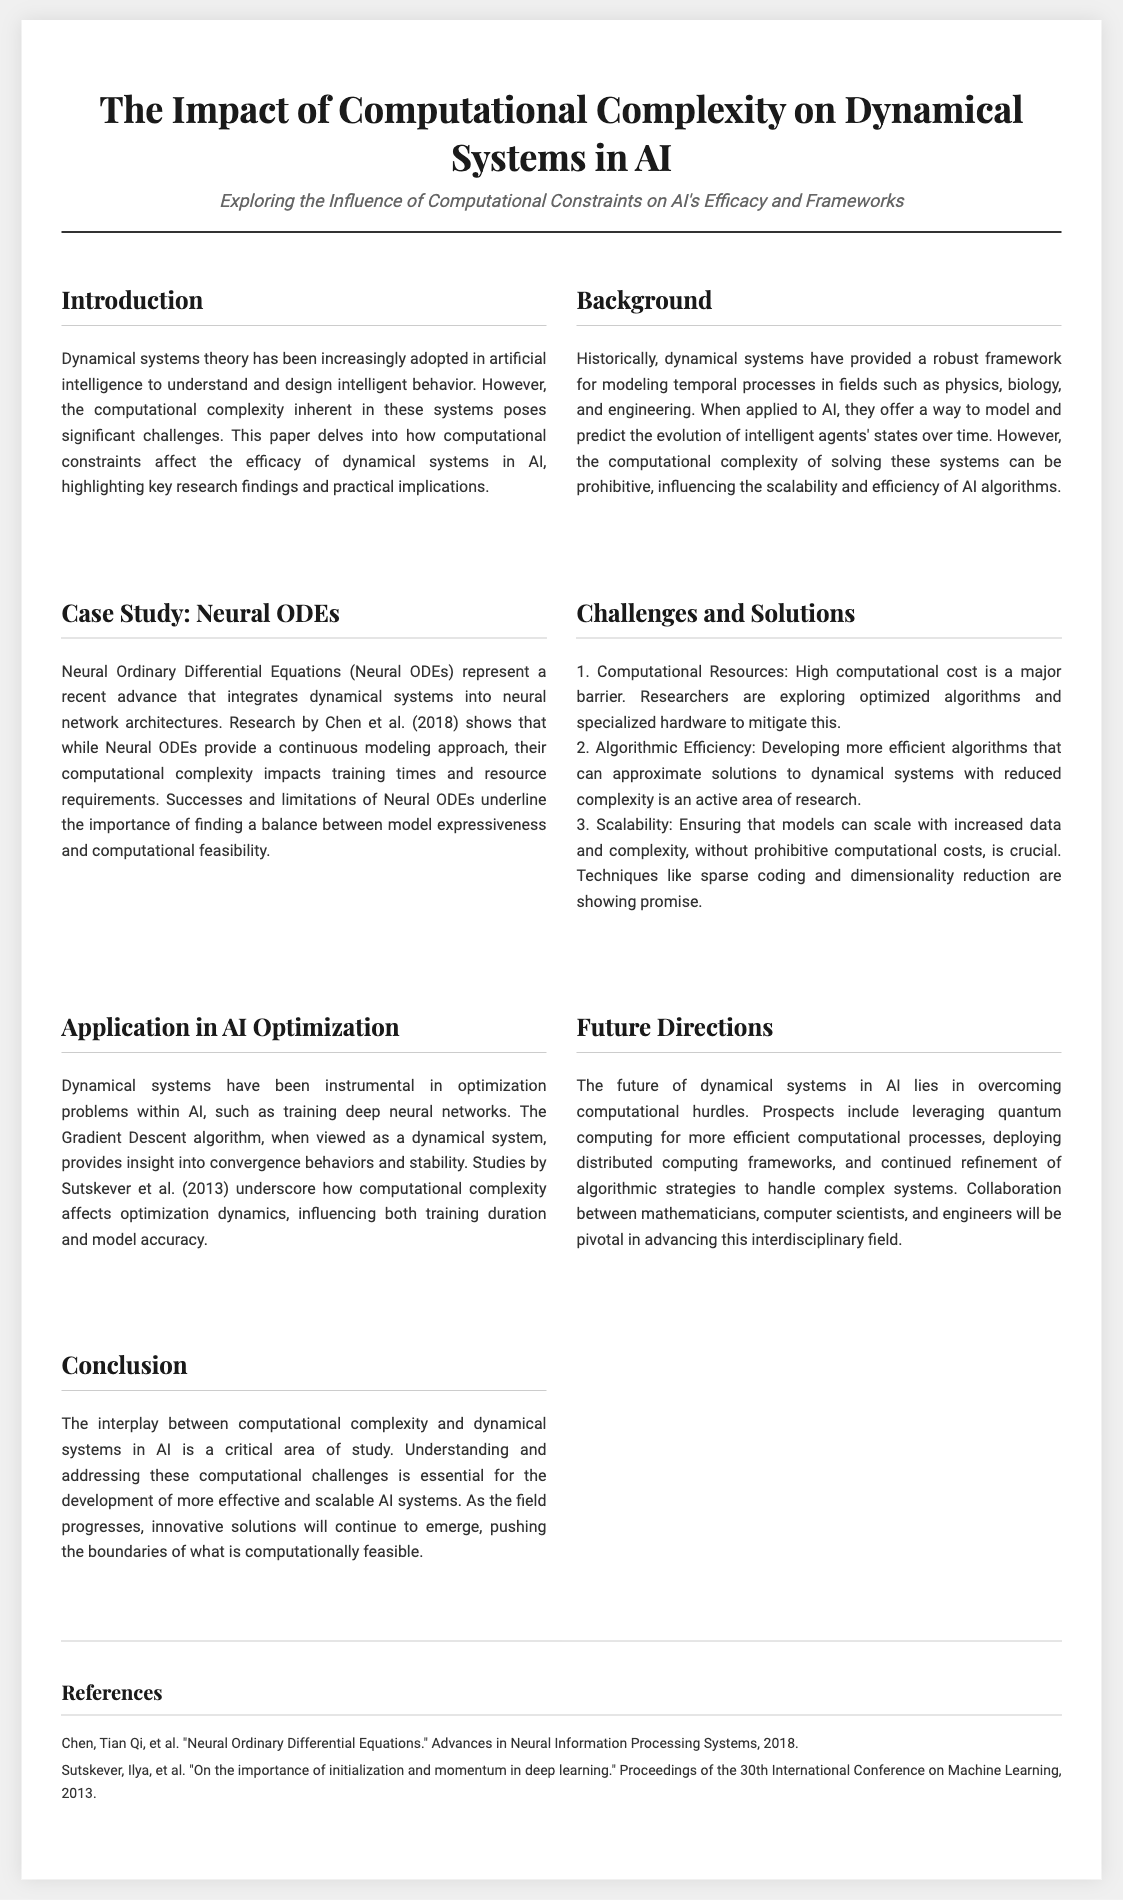What is the main focus of the paper? The main focus of the paper is to explore how computational constraints affect the efficacy of dynamical systems in AI.
Answer: Computational constraints Who are the authors mentioned in the references? The references mention two sets of authors: "Chen, Tian Qi, et al." and "Sutskever, Ilya, et al."
Answer: Chen, Tian Qi; Sutskever, Ilya What year was the research on Neural ODEs published? The research on Neural ODEs was published in the year 2018.
Answer: 2018 What challenge is associated with algorithmic efficiency? The challenge associated with algorithmic efficiency is developing more efficient algorithms that can approximate solutions to dynamical systems with reduced complexity.
Answer: Reduced complexity What do Neural ODEs represent in the context of AI? Neural ODEs represent a recent advance that integrates dynamical systems into neural network architectures.
Answer: Integrates dynamical systems What technique is mentioned as showing promise for scalability? Sparse coding and dimensionality reduction are techniques mentioned as showing promise for scalability.
Answer: Sparse coding and dimensionality reduction What is the title of the document? The title of the document is "The Impact of Computational Complexity on Dynamical Systems in AI."
Answer: The Impact of Computational Complexity on Dynamical Systems in AI What is the significance of studying the interplay between computational complexity and dynamical systems? The significance is to understand and address computational challenges essential for the development of scalable AI systems.
Answer: Scalability of AI systems 